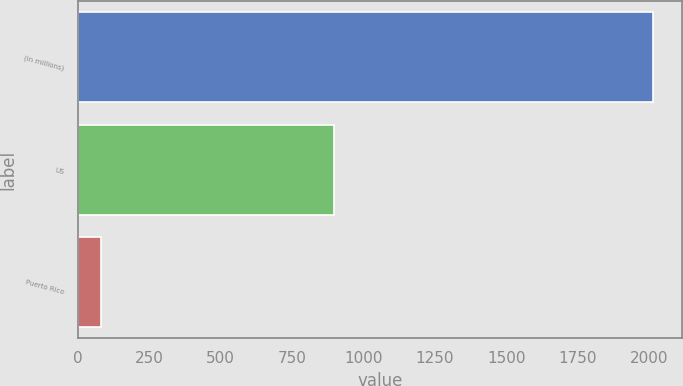Convert chart to OTSL. <chart><loc_0><loc_0><loc_500><loc_500><bar_chart><fcel>(in millions)<fcel>US<fcel>Puerto Rico<nl><fcel>2015<fcel>898<fcel>80<nl></chart> 